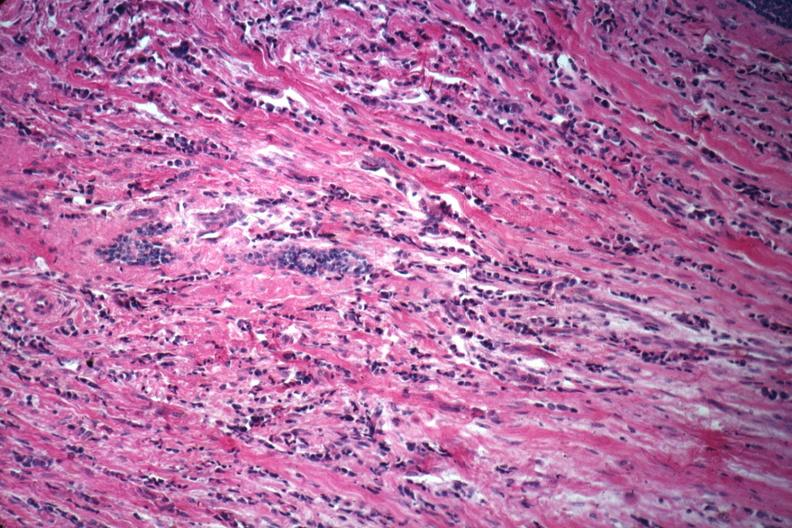what is good example of poorly differentiated?
Answer the question using a single word or phrase. Infiltrating ductal carcinoma 